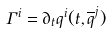Convert formula to latex. <formula><loc_0><loc_0><loc_500><loc_500>\Gamma ^ { i } = \partial _ { t } q ^ { i } ( t , \overline { q } ^ { j } )</formula> 